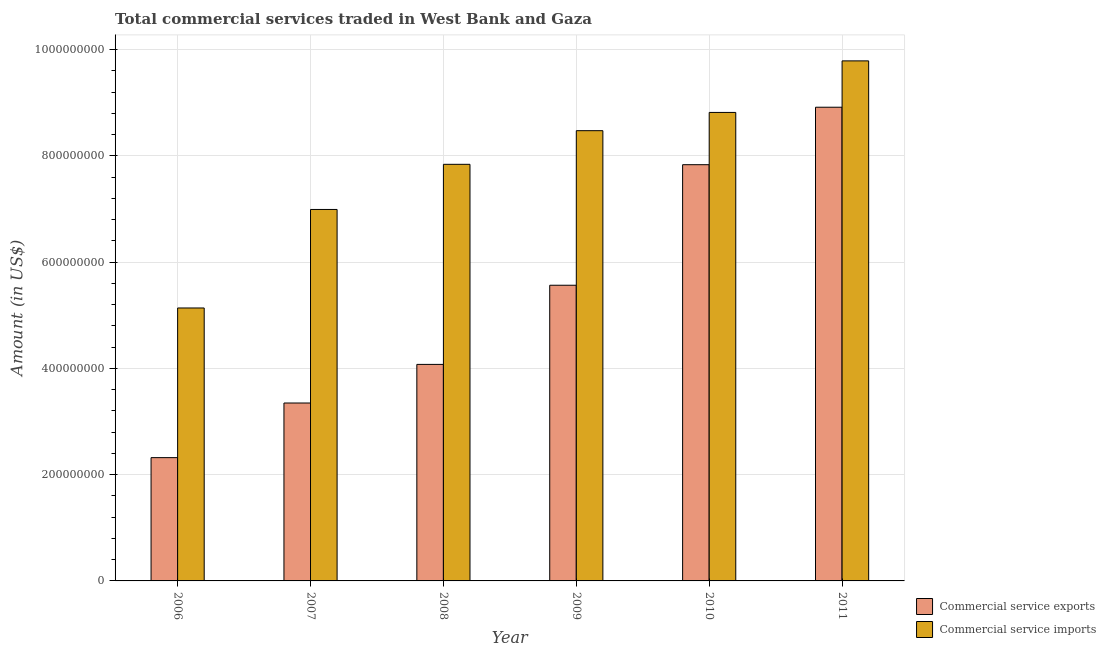How many different coloured bars are there?
Your response must be concise. 2. Are the number of bars on each tick of the X-axis equal?
Offer a very short reply. Yes. How many bars are there on the 5th tick from the left?
Provide a short and direct response. 2. How many bars are there on the 2nd tick from the right?
Keep it short and to the point. 2. What is the label of the 2nd group of bars from the left?
Provide a succinct answer. 2007. What is the amount of commercial service imports in 2009?
Your answer should be compact. 8.48e+08. Across all years, what is the maximum amount of commercial service imports?
Your response must be concise. 9.79e+08. Across all years, what is the minimum amount of commercial service imports?
Keep it short and to the point. 5.14e+08. In which year was the amount of commercial service imports maximum?
Provide a short and direct response. 2011. In which year was the amount of commercial service imports minimum?
Provide a short and direct response. 2006. What is the total amount of commercial service imports in the graph?
Your answer should be very brief. 4.71e+09. What is the difference between the amount of commercial service imports in 2008 and that in 2011?
Offer a terse response. -1.95e+08. What is the difference between the amount of commercial service exports in 2010 and the amount of commercial service imports in 2007?
Provide a short and direct response. 4.49e+08. What is the average amount of commercial service imports per year?
Ensure brevity in your answer.  7.84e+08. What is the ratio of the amount of commercial service exports in 2006 to that in 2011?
Provide a short and direct response. 0.26. Is the amount of commercial service imports in 2008 less than that in 2010?
Provide a succinct answer. Yes. Is the difference between the amount of commercial service exports in 2008 and 2010 greater than the difference between the amount of commercial service imports in 2008 and 2010?
Your response must be concise. No. What is the difference between the highest and the second highest amount of commercial service imports?
Make the answer very short. 9.70e+07. What is the difference between the highest and the lowest amount of commercial service imports?
Ensure brevity in your answer.  4.65e+08. In how many years, is the amount of commercial service imports greater than the average amount of commercial service imports taken over all years?
Make the answer very short. 3. Is the sum of the amount of commercial service exports in 2006 and 2011 greater than the maximum amount of commercial service imports across all years?
Your answer should be very brief. Yes. What does the 2nd bar from the left in 2007 represents?
Your answer should be very brief. Commercial service imports. What does the 1st bar from the right in 2006 represents?
Provide a succinct answer. Commercial service imports. Are the values on the major ticks of Y-axis written in scientific E-notation?
Provide a short and direct response. No. Does the graph contain any zero values?
Provide a succinct answer. No. How many legend labels are there?
Ensure brevity in your answer.  2. How are the legend labels stacked?
Your response must be concise. Vertical. What is the title of the graph?
Provide a succinct answer. Total commercial services traded in West Bank and Gaza. What is the label or title of the X-axis?
Provide a succinct answer. Year. What is the Amount (in US$) of Commercial service exports in 2006?
Give a very brief answer. 2.32e+08. What is the Amount (in US$) in Commercial service imports in 2006?
Ensure brevity in your answer.  5.14e+08. What is the Amount (in US$) of Commercial service exports in 2007?
Your answer should be very brief. 3.35e+08. What is the Amount (in US$) in Commercial service imports in 2007?
Offer a terse response. 6.99e+08. What is the Amount (in US$) in Commercial service exports in 2008?
Provide a succinct answer. 4.08e+08. What is the Amount (in US$) in Commercial service imports in 2008?
Offer a terse response. 7.84e+08. What is the Amount (in US$) in Commercial service exports in 2009?
Give a very brief answer. 5.57e+08. What is the Amount (in US$) in Commercial service imports in 2009?
Ensure brevity in your answer.  8.48e+08. What is the Amount (in US$) of Commercial service exports in 2010?
Your answer should be compact. 7.83e+08. What is the Amount (in US$) of Commercial service imports in 2010?
Offer a terse response. 8.82e+08. What is the Amount (in US$) of Commercial service exports in 2011?
Your answer should be very brief. 8.92e+08. What is the Amount (in US$) in Commercial service imports in 2011?
Your response must be concise. 9.79e+08. Across all years, what is the maximum Amount (in US$) in Commercial service exports?
Offer a very short reply. 8.92e+08. Across all years, what is the maximum Amount (in US$) of Commercial service imports?
Make the answer very short. 9.79e+08. Across all years, what is the minimum Amount (in US$) of Commercial service exports?
Make the answer very short. 2.32e+08. Across all years, what is the minimum Amount (in US$) in Commercial service imports?
Provide a succinct answer. 5.14e+08. What is the total Amount (in US$) of Commercial service exports in the graph?
Offer a terse response. 3.21e+09. What is the total Amount (in US$) of Commercial service imports in the graph?
Keep it short and to the point. 4.71e+09. What is the difference between the Amount (in US$) in Commercial service exports in 2006 and that in 2007?
Give a very brief answer. -1.03e+08. What is the difference between the Amount (in US$) of Commercial service imports in 2006 and that in 2007?
Ensure brevity in your answer.  -1.85e+08. What is the difference between the Amount (in US$) in Commercial service exports in 2006 and that in 2008?
Offer a terse response. -1.76e+08. What is the difference between the Amount (in US$) in Commercial service imports in 2006 and that in 2008?
Offer a very short reply. -2.70e+08. What is the difference between the Amount (in US$) in Commercial service exports in 2006 and that in 2009?
Provide a succinct answer. -3.24e+08. What is the difference between the Amount (in US$) of Commercial service imports in 2006 and that in 2009?
Offer a terse response. -3.34e+08. What is the difference between the Amount (in US$) in Commercial service exports in 2006 and that in 2010?
Ensure brevity in your answer.  -5.51e+08. What is the difference between the Amount (in US$) of Commercial service imports in 2006 and that in 2010?
Offer a terse response. -3.68e+08. What is the difference between the Amount (in US$) of Commercial service exports in 2006 and that in 2011?
Keep it short and to the point. -6.60e+08. What is the difference between the Amount (in US$) of Commercial service imports in 2006 and that in 2011?
Make the answer very short. -4.65e+08. What is the difference between the Amount (in US$) in Commercial service exports in 2007 and that in 2008?
Provide a succinct answer. -7.27e+07. What is the difference between the Amount (in US$) of Commercial service imports in 2007 and that in 2008?
Give a very brief answer. -8.50e+07. What is the difference between the Amount (in US$) of Commercial service exports in 2007 and that in 2009?
Your response must be concise. -2.22e+08. What is the difference between the Amount (in US$) in Commercial service imports in 2007 and that in 2009?
Your response must be concise. -1.48e+08. What is the difference between the Amount (in US$) of Commercial service exports in 2007 and that in 2010?
Make the answer very short. -4.49e+08. What is the difference between the Amount (in US$) in Commercial service imports in 2007 and that in 2010?
Offer a very short reply. -1.83e+08. What is the difference between the Amount (in US$) of Commercial service exports in 2007 and that in 2011?
Give a very brief answer. -5.57e+08. What is the difference between the Amount (in US$) of Commercial service imports in 2007 and that in 2011?
Offer a terse response. -2.80e+08. What is the difference between the Amount (in US$) of Commercial service exports in 2008 and that in 2009?
Make the answer very short. -1.49e+08. What is the difference between the Amount (in US$) of Commercial service imports in 2008 and that in 2009?
Keep it short and to the point. -6.33e+07. What is the difference between the Amount (in US$) in Commercial service exports in 2008 and that in 2010?
Your answer should be very brief. -3.76e+08. What is the difference between the Amount (in US$) in Commercial service imports in 2008 and that in 2010?
Your response must be concise. -9.77e+07. What is the difference between the Amount (in US$) in Commercial service exports in 2008 and that in 2011?
Your response must be concise. -4.84e+08. What is the difference between the Amount (in US$) of Commercial service imports in 2008 and that in 2011?
Your answer should be compact. -1.95e+08. What is the difference between the Amount (in US$) of Commercial service exports in 2009 and that in 2010?
Your answer should be very brief. -2.27e+08. What is the difference between the Amount (in US$) of Commercial service imports in 2009 and that in 2010?
Your answer should be very brief. -3.43e+07. What is the difference between the Amount (in US$) of Commercial service exports in 2009 and that in 2011?
Your response must be concise. -3.35e+08. What is the difference between the Amount (in US$) in Commercial service imports in 2009 and that in 2011?
Offer a very short reply. -1.31e+08. What is the difference between the Amount (in US$) in Commercial service exports in 2010 and that in 2011?
Offer a very short reply. -1.08e+08. What is the difference between the Amount (in US$) of Commercial service imports in 2010 and that in 2011?
Make the answer very short. -9.70e+07. What is the difference between the Amount (in US$) of Commercial service exports in 2006 and the Amount (in US$) of Commercial service imports in 2007?
Your answer should be compact. -4.67e+08. What is the difference between the Amount (in US$) of Commercial service exports in 2006 and the Amount (in US$) of Commercial service imports in 2008?
Your answer should be very brief. -5.52e+08. What is the difference between the Amount (in US$) of Commercial service exports in 2006 and the Amount (in US$) of Commercial service imports in 2009?
Provide a succinct answer. -6.15e+08. What is the difference between the Amount (in US$) of Commercial service exports in 2006 and the Amount (in US$) of Commercial service imports in 2010?
Your answer should be very brief. -6.50e+08. What is the difference between the Amount (in US$) in Commercial service exports in 2006 and the Amount (in US$) in Commercial service imports in 2011?
Ensure brevity in your answer.  -7.47e+08. What is the difference between the Amount (in US$) of Commercial service exports in 2007 and the Amount (in US$) of Commercial service imports in 2008?
Your response must be concise. -4.49e+08. What is the difference between the Amount (in US$) of Commercial service exports in 2007 and the Amount (in US$) of Commercial service imports in 2009?
Offer a terse response. -5.13e+08. What is the difference between the Amount (in US$) in Commercial service exports in 2007 and the Amount (in US$) in Commercial service imports in 2010?
Your answer should be very brief. -5.47e+08. What is the difference between the Amount (in US$) in Commercial service exports in 2007 and the Amount (in US$) in Commercial service imports in 2011?
Give a very brief answer. -6.44e+08. What is the difference between the Amount (in US$) of Commercial service exports in 2008 and the Amount (in US$) of Commercial service imports in 2009?
Offer a very short reply. -4.40e+08. What is the difference between the Amount (in US$) of Commercial service exports in 2008 and the Amount (in US$) of Commercial service imports in 2010?
Provide a succinct answer. -4.74e+08. What is the difference between the Amount (in US$) in Commercial service exports in 2008 and the Amount (in US$) in Commercial service imports in 2011?
Ensure brevity in your answer.  -5.71e+08. What is the difference between the Amount (in US$) in Commercial service exports in 2009 and the Amount (in US$) in Commercial service imports in 2010?
Your answer should be compact. -3.25e+08. What is the difference between the Amount (in US$) of Commercial service exports in 2009 and the Amount (in US$) of Commercial service imports in 2011?
Ensure brevity in your answer.  -4.22e+08. What is the difference between the Amount (in US$) in Commercial service exports in 2010 and the Amount (in US$) in Commercial service imports in 2011?
Provide a succinct answer. -1.95e+08. What is the average Amount (in US$) in Commercial service exports per year?
Provide a short and direct response. 5.34e+08. What is the average Amount (in US$) of Commercial service imports per year?
Offer a terse response. 7.84e+08. In the year 2006, what is the difference between the Amount (in US$) of Commercial service exports and Amount (in US$) of Commercial service imports?
Provide a succinct answer. -2.82e+08. In the year 2007, what is the difference between the Amount (in US$) in Commercial service exports and Amount (in US$) in Commercial service imports?
Give a very brief answer. -3.64e+08. In the year 2008, what is the difference between the Amount (in US$) in Commercial service exports and Amount (in US$) in Commercial service imports?
Keep it short and to the point. -3.77e+08. In the year 2009, what is the difference between the Amount (in US$) of Commercial service exports and Amount (in US$) of Commercial service imports?
Give a very brief answer. -2.91e+08. In the year 2010, what is the difference between the Amount (in US$) in Commercial service exports and Amount (in US$) in Commercial service imports?
Offer a very short reply. -9.84e+07. In the year 2011, what is the difference between the Amount (in US$) in Commercial service exports and Amount (in US$) in Commercial service imports?
Make the answer very short. -8.73e+07. What is the ratio of the Amount (in US$) of Commercial service exports in 2006 to that in 2007?
Ensure brevity in your answer.  0.69. What is the ratio of the Amount (in US$) of Commercial service imports in 2006 to that in 2007?
Ensure brevity in your answer.  0.73. What is the ratio of the Amount (in US$) of Commercial service exports in 2006 to that in 2008?
Your answer should be compact. 0.57. What is the ratio of the Amount (in US$) in Commercial service imports in 2006 to that in 2008?
Provide a succinct answer. 0.66. What is the ratio of the Amount (in US$) of Commercial service exports in 2006 to that in 2009?
Ensure brevity in your answer.  0.42. What is the ratio of the Amount (in US$) in Commercial service imports in 2006 to that in 2009?
Your answer should be compact. 0.61. What is the ratio of the Amount (in US$) of Commercial service exports in 2006 to that in 2010?
Your response must be concise. 0.3. What is the ratio of the Amount (in US$) in Commercial service imports in 2006 to that in 2010?
Ensure brevity in your answer.  0.58. What is the ratio of the Amount (in US$) in Commercial service exports in 2006 to that in 2011?
Your answer should be compact. 0.26. What is the ratio of the Amount (in US$) of Commercial service imports in 2006 to that in 2011?
Your response must be concise. 0.52. What is the ratio of the Amount (in US$) in Commercial service exports in 2007 to that in 2008?
Make the answer very short. 0.82. What is the ratio of the Amount (in US$) of Commercial service imports in 2007 to that in 2008?
Your response must be concise. 0.89. What is the ratio of the Amount (in US$) in Commercial service exports in 2007 to that in 2009?
Give a very brief answer. 0.6. What is the ratio of the Amount (in US$) of Commercial service imports in 2007 to that in 2009?
Offer a terse response. 0.82. What is the ratio of the Amount (in US$) in Commercial service exports in 2007 to that in 2010?
Provide a short and direct response. 0.43. What is the ratio of the Amount (in US$) in Commercial service imports in 2007 to that in 2010?
Offer a very short reply. 0.79. What is the ratio of the Amount (in US$) in Commercial service exports in 2007 to that in 2011?
Offer a very short reply. 0.38. What is the ratio of the Amount (in US$) in Commercial service exports in 2008 to that in 2009?
Your response must be concise. 0.73. What is the ratio of the Amount (in US$) of Commercial service imports in 2008 to that in 2009?
Your answer should be very brief. 0.93. What is the ratio of the Amount (in US$) in Commercial service exports in 2008 to that in 2010?
Your answer should be compact. 0.52. What is the ratio of the Amount (in US$) in Commercial service imports in 2008 to that in 2010?
Your answer should be compact. 0.89. What is the ratio of the Amount (in US$) of Commercial service exports in 2008 to that in 2011?
Make the answer very short. 0.46. What is the ratio of the Amount (in US$) of Commercial service imports in 2008 to that in 2011?
Your response must be concise. 0.8. What is the ratio of the Amount (in US$) of Commercial service exports in 2009 to that in 2010?
Offer a terse response. 0.71. What is the ratio of the Amount (in US$) of Commercial service imports in 2009 to that in 2010?
Make the answer very short. 0.96. What is the ratio of the Amount (in US$) in Commercial service exports in 2009 to that in 2011?
Your answer should be very brief. 0.62. What is the ratio of the Amount (in US$) in Commercial service imports in 2009 to that in 2011?
Your answer should be compact. 0.87. What is the ratio of the Amount (in US$) in Commercial service exports in 2010 to that in 2011?
Your answer should be compact. 0.88. What is the ratio of the Amount (in US$) in Commercial service imports in 2010 to that in 2011?
Your answer should be very brief. 0.9. What is the difference between the highest and the second highest Amount (in US$) of Commercial service exports?
Offer a very short reply. 1.08e+08. What is the difference between the highest and the second highest Amount (in US$) of Commercial service imports?
Give a very brief answer. 9.70e+07. What is the difference between the highest and the lowest Amount (in US$) of Commercial service exports?
Provide a succinct answer. 6.60e+08. What is the difference between the highest and the lowest Amount (in US$) in Commercial service imports?
Offer a very short reply. 4.65e+08. 